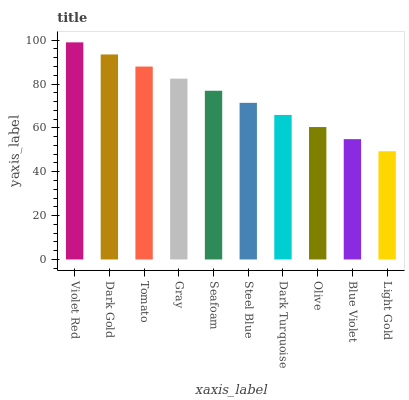Is Light Gold the minimum?
Answer yes or no. Yes. Is Violet Red the maximum?
Answer yes or no. Yes. Is Dark Gold the minimum?
Answer yes or no. No. Is Dark Gold the maximum?
Answer yes or no. No. Is Violet Red greater than Dark Gold?
Answer yes or no. Yes. Is Dark Gold less than Violet Red?
Answer yes or no. Yes. Is Dark Gold greater than Violet Red?
Answer yes or no. No. Is Violet Red less than Dark Gold?
Answer yes or no. No. Is Seafoam the high median?
Answer yes or no. Yes. Is Steel Blue the low median?
Answer yes or no. Yes. Is Gray the high median?
Answer yes or no. No. Is Light Gold the low median?
Answer yes or no. No. 